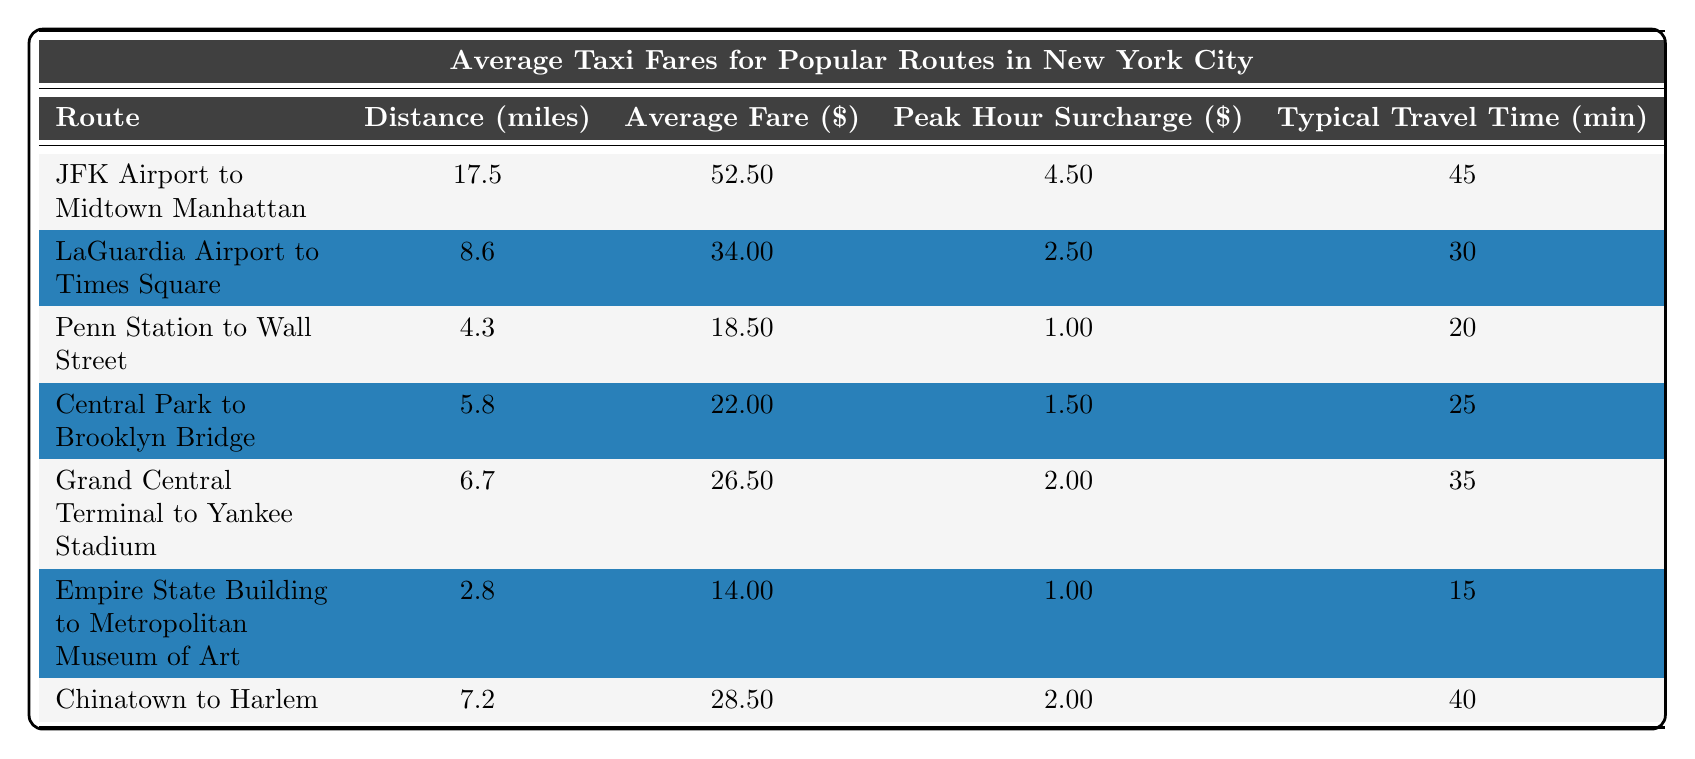What is the average fare for a taxi ride from JFK Airport to Midtown Manhattan? The average fare for this route is listed in the table under the "Average Fare ($)" column. For JFK Airport to Midtown Manhattan, the fare is $52.50.
Answer: 52.50 How much is the peak hour surcharge for a ride from LaGuardia Airport to Times Square? The peak hour surcharge for this route is found in the "Peak Hour Surcharge ($)" column. It is noted as $2.50 for this ride.
Answer: 2.50 What is the typical travel time from Penn Station to Wall Street? The typical travel time is given in the "Typical Travel Time (minutes)" column. For this route, it takes approximately 20 minutes.
Answer: 20 Which route has the longest distance to travel? By reviewing the "Distance (miles)" column, the longest distance is 17.5 miles for the route from JFK Airport to Midtown Manhattan.
Answer: JFK Airport to Midtown Manhattan Calculate the total average fare for a ride from Central Park to Brooklyn Bridge and from Grand Central Terminal to Yankee Stadium. The average fare for Central Park to Brooklyn Bridge is $22.00, and for Grand Central Terminal to Yankee Stadium, it is $26.50. Summing these fares gives $22.00 + $26.50 = $48.50.
Answer: 48.50 Does the distance from Chinatown to Harlem exceed 7 miles? Checking the "Distance (miles)" column, Chinatown to Harlem has a distance of 7.2 miles. Since 7.2 miles is greater than 7 miles, the statement is true.
Answer: Yes Which route has the lowest average fare? The "Average Fare ($)" column shows the fares, and Empire State Building to Metropolitan Museum of Art has the lowest fare at $14.00.
Answer: Empire State Building to Metropolitan Museum of Art What is the average travel time for routes that have an average fare below $30? Evaluating the routes below $30: Penn Station to Wall Street (20 minutes), Central Park to Brooklyn Bridge (25 minutes), Empire State Building to Metropolitan Museum of Art (15 minutes), and Chinatown to Harlem (40 minutes). Adding these times gives 20 + 25 + 15 + 40 = 100 minutes. Dividing by 4 routes gives an average of 100/4 = 25 minutes.
Answer: 25 What is the peak hour surcharge for the route with the shortest distance? The route with the shortest distance is from Empire State Building to Metropolitan Museum of Art, which has a distance of 2.8 miles. Its peak hour surcharge is noted as $1.00.
Answer: 1.00 Are there any routes where the peak hour surcharge exceeds $3.00? By examining the "Peak Hour Surcharge ($)" column, the highest surcharge is $4.50 for JFK Airport to Midtown Manhattan. Since $4.50 is greater than $3.00, the answer is yes.
Answer: Yes 